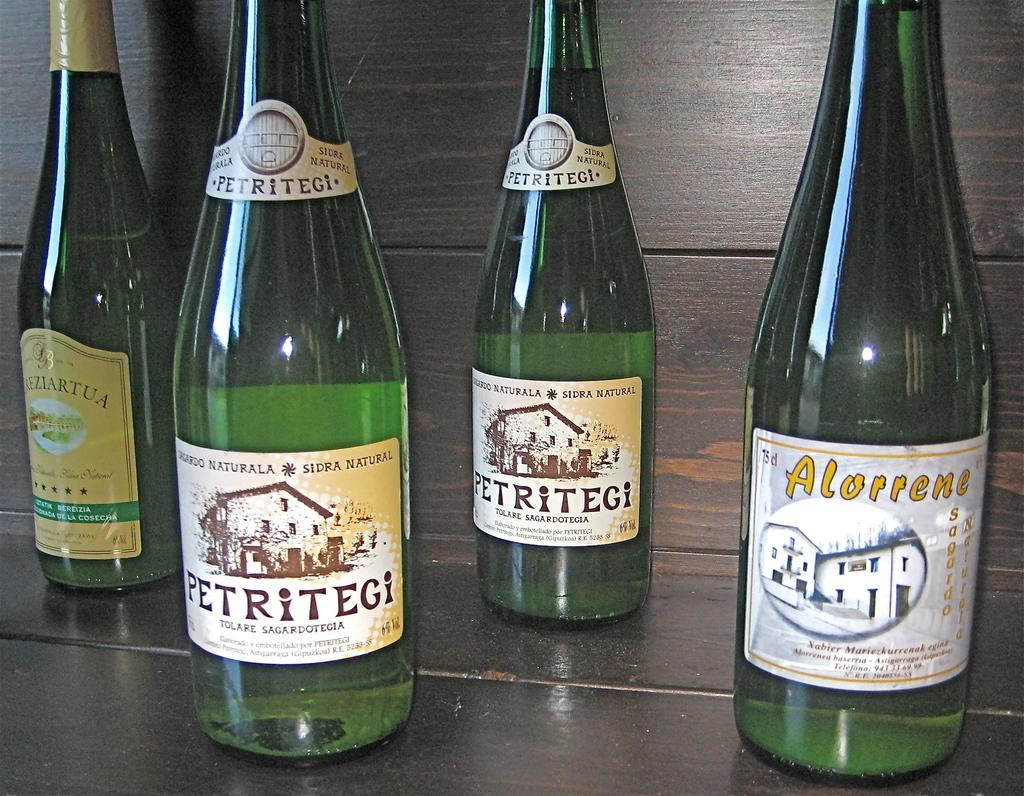<image>
Create a compact narrative representing the image presented. A PETRITEGI BOTTLE IS NEXT TO A BOTTLE OF ALORRENE 